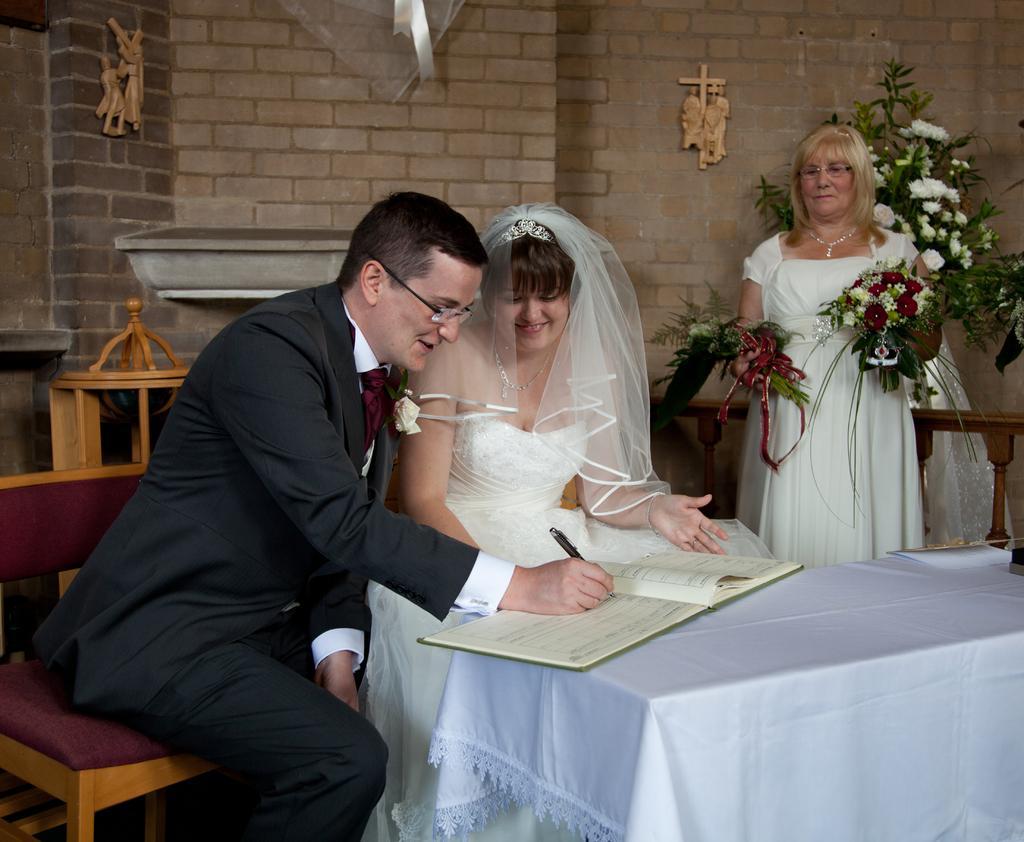How would you summarize this image in a sentence or two? In this image we can see a man and a smiling woman sitting on the chairs in front of the table which is covered with the cloth and we can see the man holding the pen and writing on the book. There is also another book on the table. In the background, we can see a woman holding the bouquets. We can also see the flower pot and some objects are attached to the brick wall. 